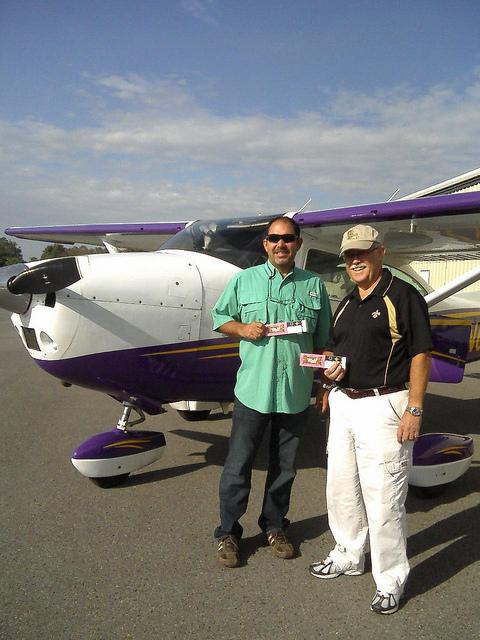What are these men displaying? tickets 